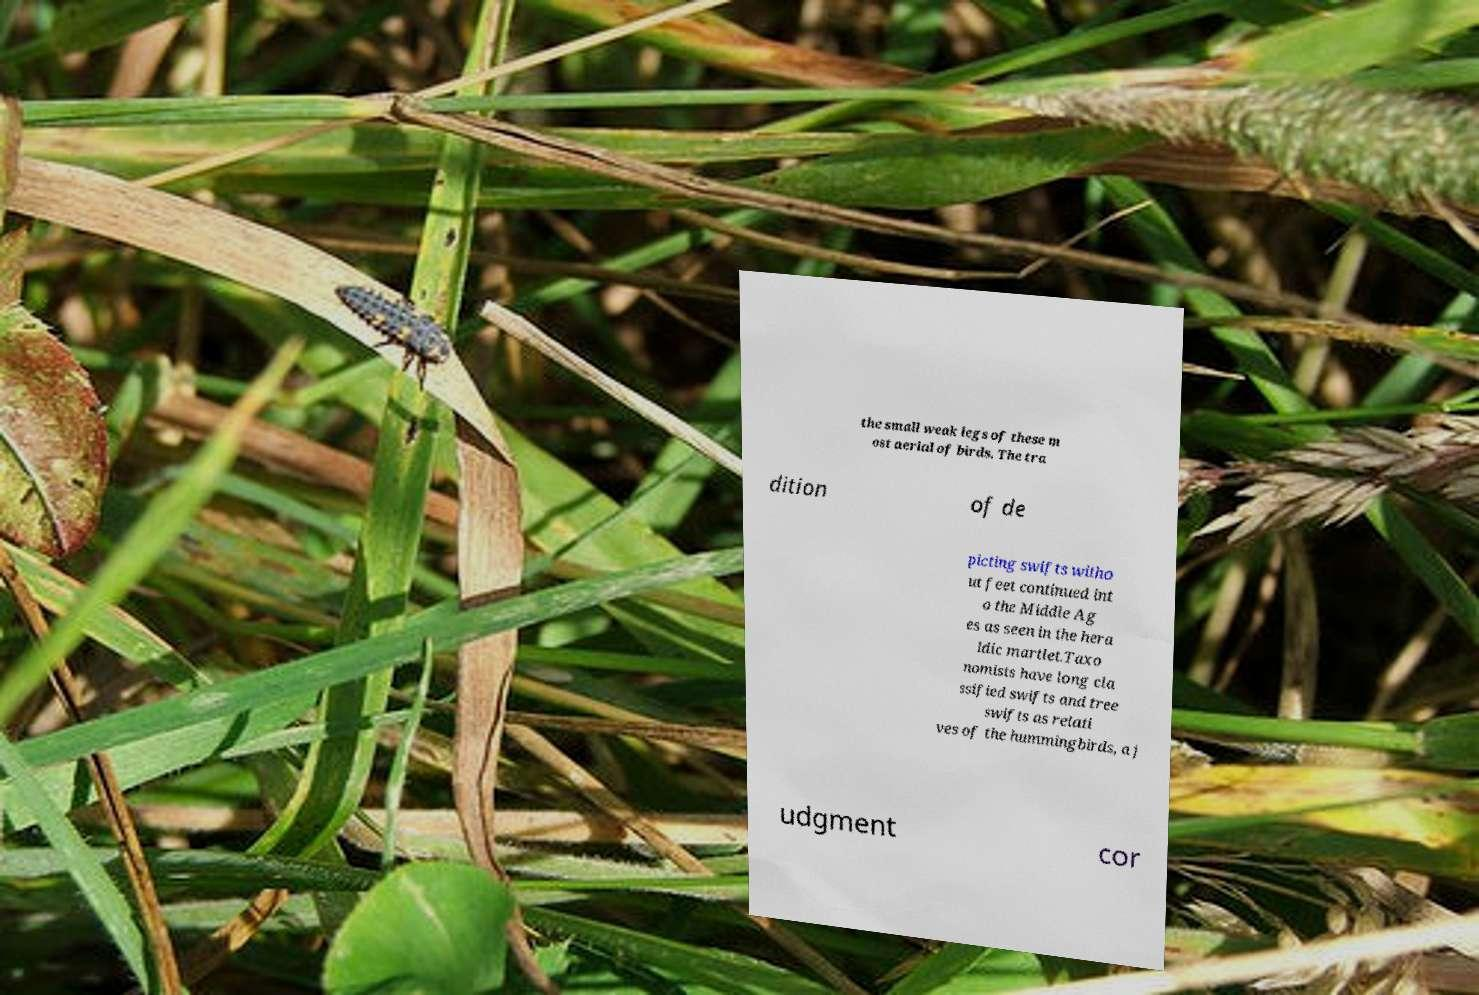Please identify and transcribe the text found in this image. the small weak legs of these m ost aerial of birds. The tra dition of de picting swifts witho ut feet continued int o the Middle Ag es as seen in the hera ldic martlet.Taxo nomists have long cla ssified swifts and tree swifts as relati ves of the hummingbirds, a j udgment cor 